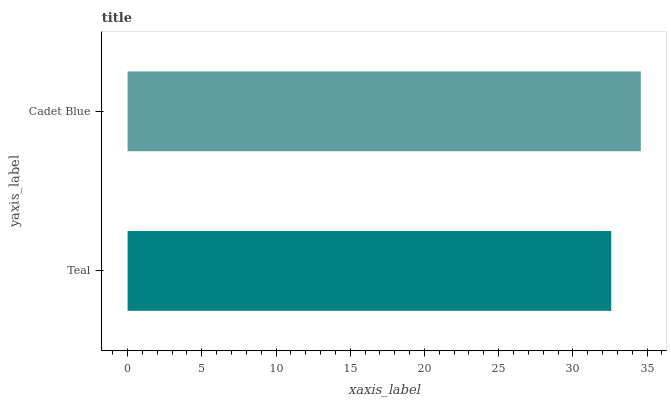Is Teal the minimum?
Answer yes or no. Yes. Is Cadet Blue the maximum?
Answer yes or no. Yes. Is Cadet Blue the minimum?
Answer yes or no. No. Is Cadet Blue greater than Teal?
Answer yes or no. Yes. Is Teal less than Cadet Blue?
Answer yes or no. Yes. Is Teal greater than Cadet Blue?
Answer yes or no. No. Is Cadet Blue less than Teal?
Answer yes or no. No. Is Cadet Blue the high median?
Answer yes or no. Yes. Is Teal the low median?
Answer yes or no. Yes. Is Teal the high median?
Answer yes or no. No. Is Cadet Blue the low median?
Answer yes or no. No. 